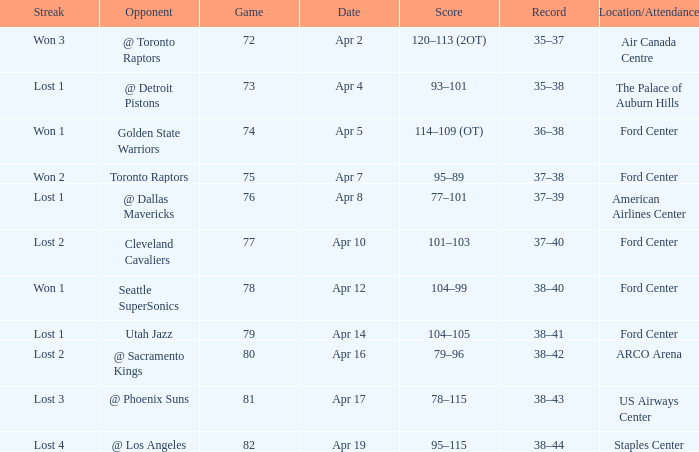What was the record for less than 78 games and a score of 114–109 (ot)? 36–38. 